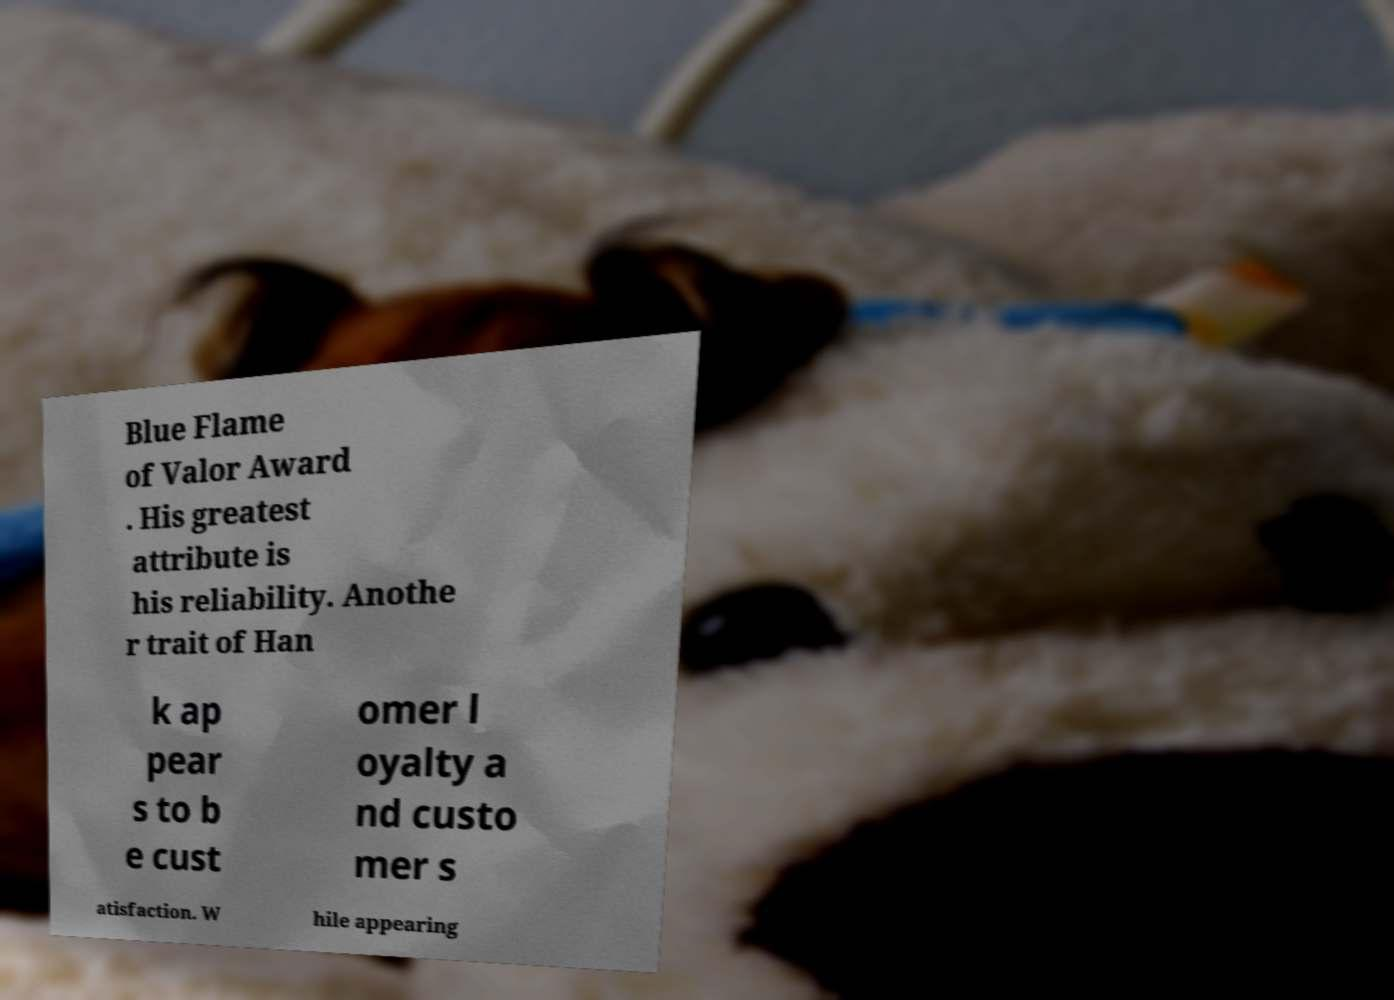Please identify and transcribe the text found in this image. Blue Flame of Valor Award . His greatest attribute is his reliability. Anothe r trait of Han k ap pear s to b e cust omer l oyalty a nd custo mer s atisfaction. W hile appearing 